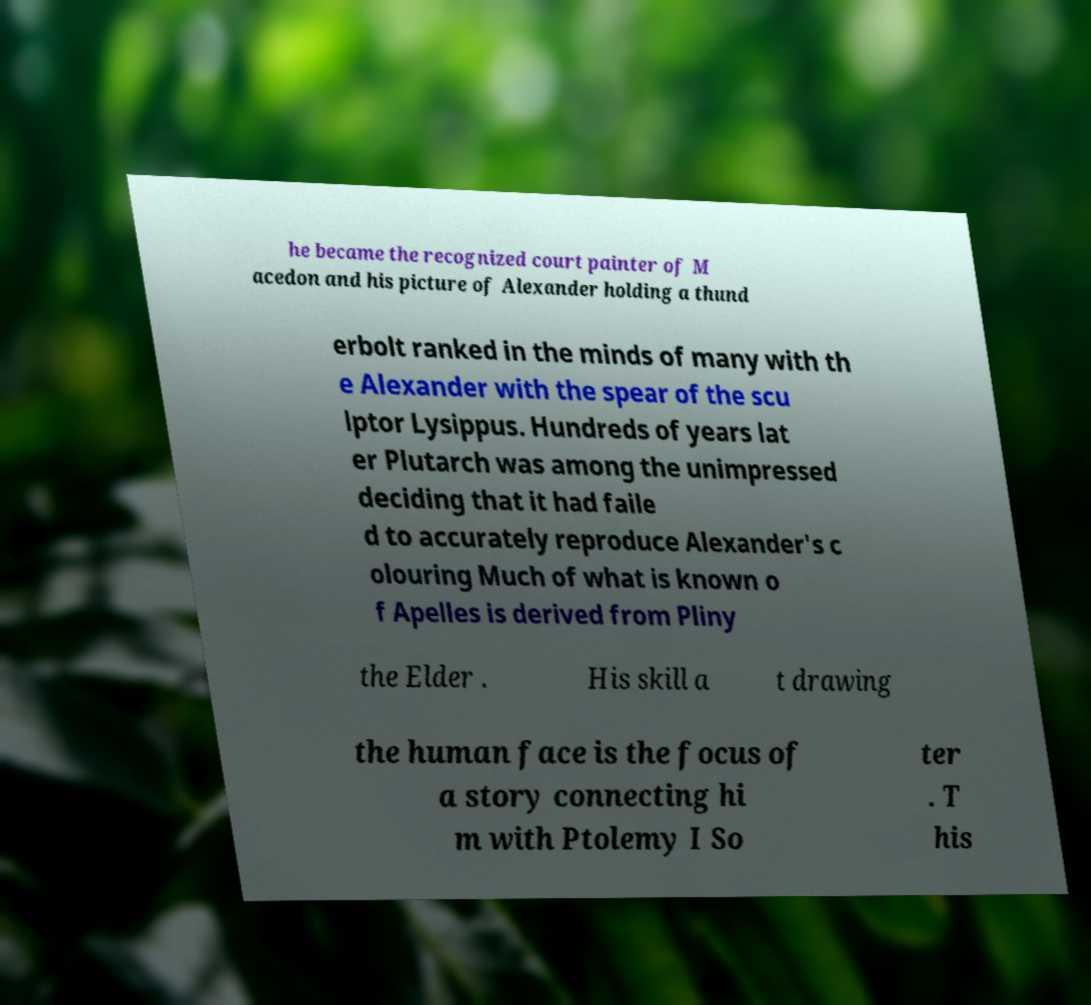Could you extract and type out the text from this image? he became the recognized court painter of M acedon and his picture of Alexander holding a thund erbolt ranked in the minds of many with th e Alexander with the spear of the scu lptor Lysippus. Hundreds of years lat er Plutarch was among the unimpressed deciding that it had faile d to accurately reproduce Alexander's c olouring Much of what is known o f Apelles is derived from Pliny the Elder . His skill a t drawing the human face is the focus of a story connecting hi m with Ptolemy I So ter . T his 